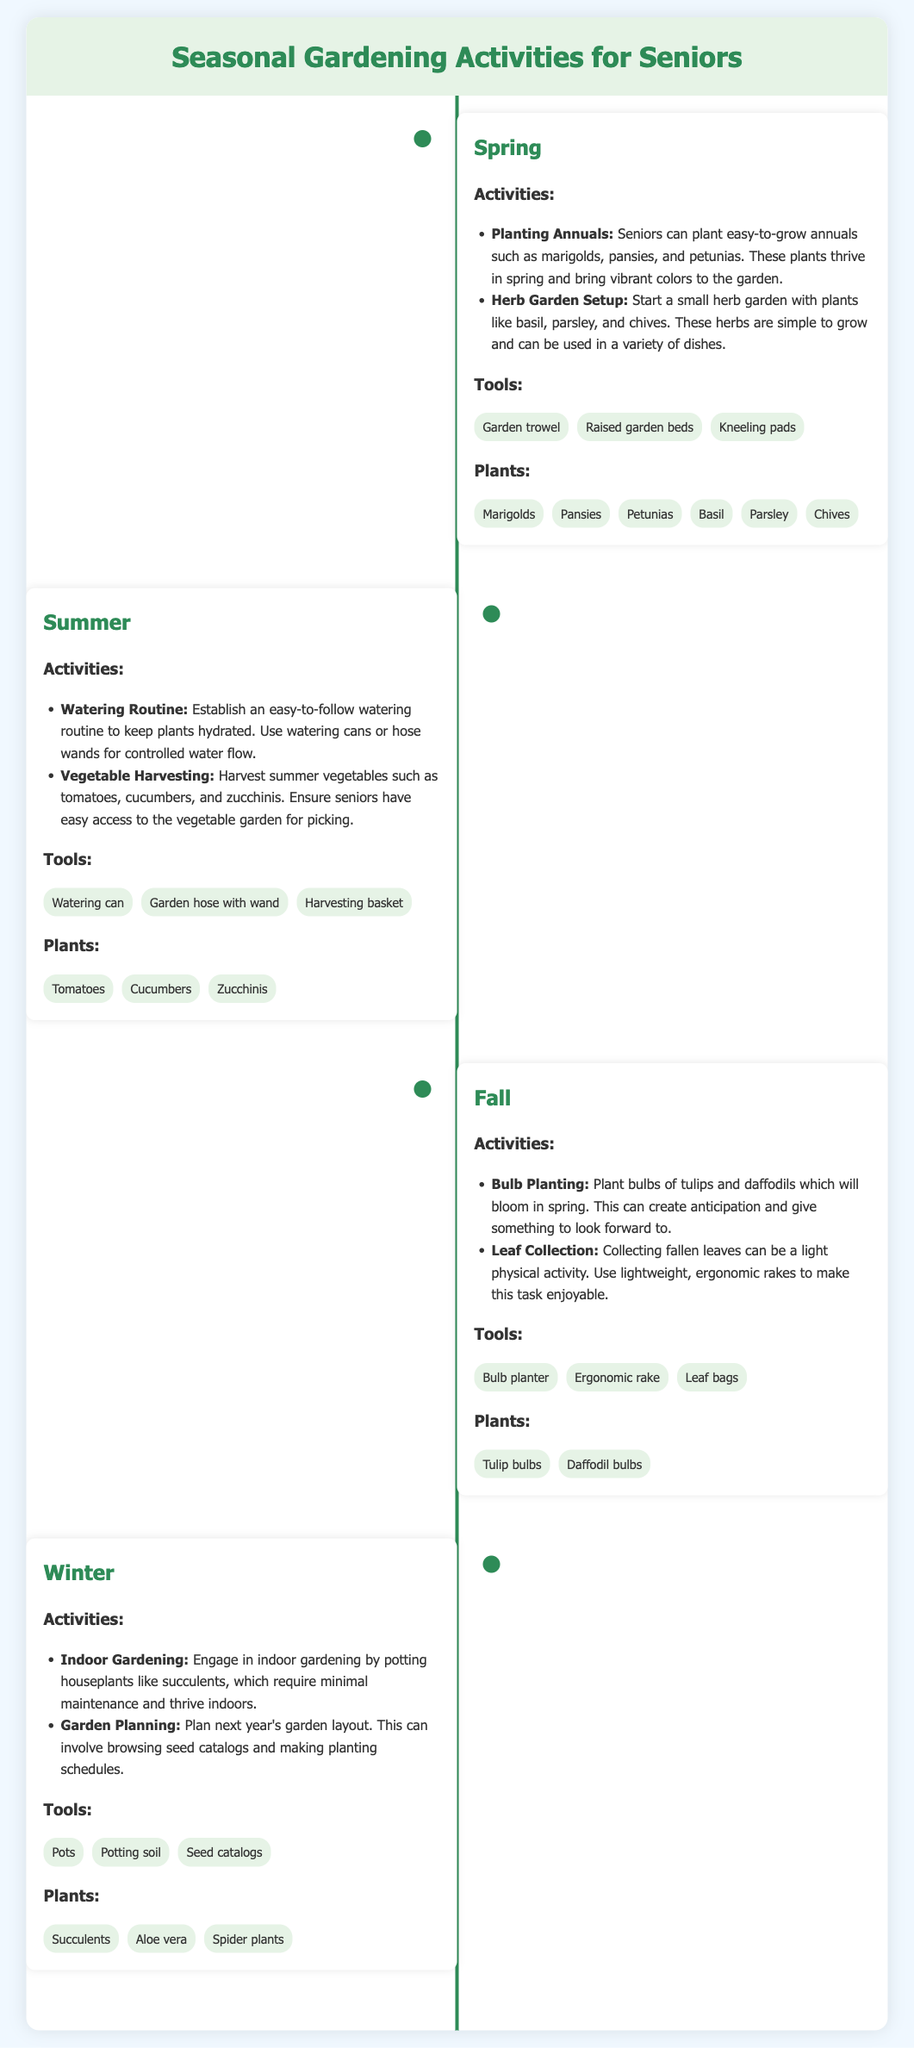What season includes planting annuals like marigolds? The document states that planting annuals is a spring activity.
Answer: Spring Which tools are recommended for summer gardening? The document lists tools for summer activities, which include a watering can, garden hose with wand, and harvesting basket.
Answer: Watering can, garden hose with wand, harvesting basket What are two activities suggested for fall? The document mentions two activities for fall: bulb planting and leaf collection.
Answer: Bulb planting, leaf collection How many plants are mentioned for each season? The document lists six plants for spring, three for summer, two for fall, and three for winter, totaling fourteen plants.
Answer: Fourteen plants Which gardening activity involves browsing seed catalogs? The document describes garden planning in winter, which includes browsing seed catalogs.
Answer: Garden planning What is one type of plant recommended for indoor gardening? The document suggests potting houseplants, including succulents, for indoor gardening activities.
Answer: Succulents What is a common tool listed for bulb planting? The document lists a bulb planter as a tool for the fall activity of bulb planting.
Answer: Bulb planter Which season's activities include harvest of tomatoes? The document states that harvesting tomatoes is a summer activity.
Answer: Summer 